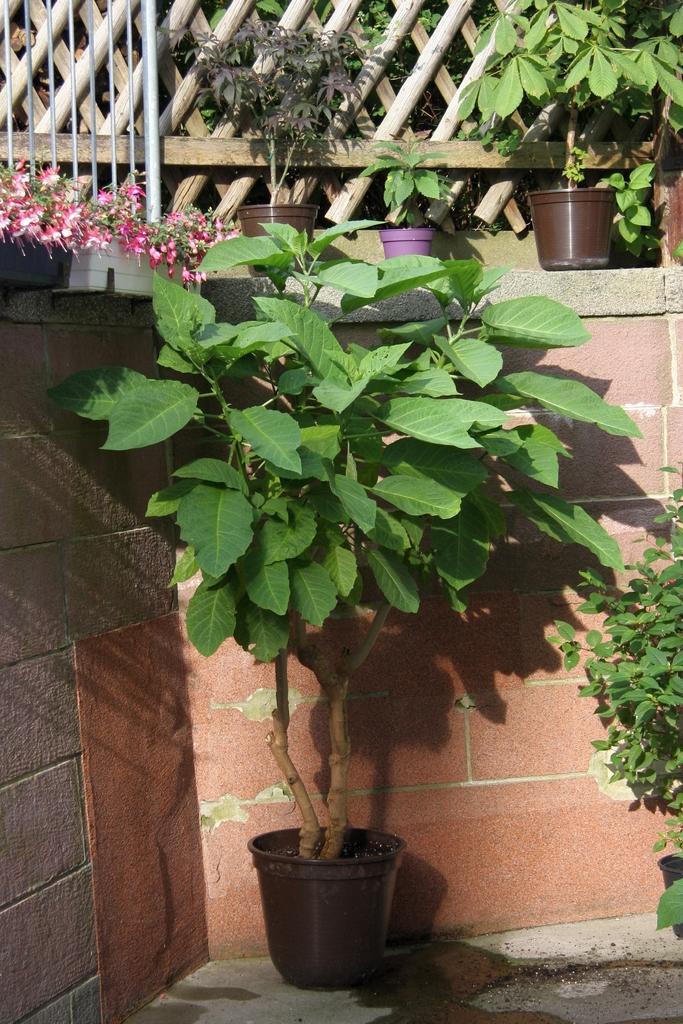Describe this image in one or two sentences. In this picture, we see flowers pots and plants. On the right side, we see a plant. Behind that, we see a wall. At the top, we see the flower pots and the flowers which are in pink color. In the background, we see the wooden fence. 